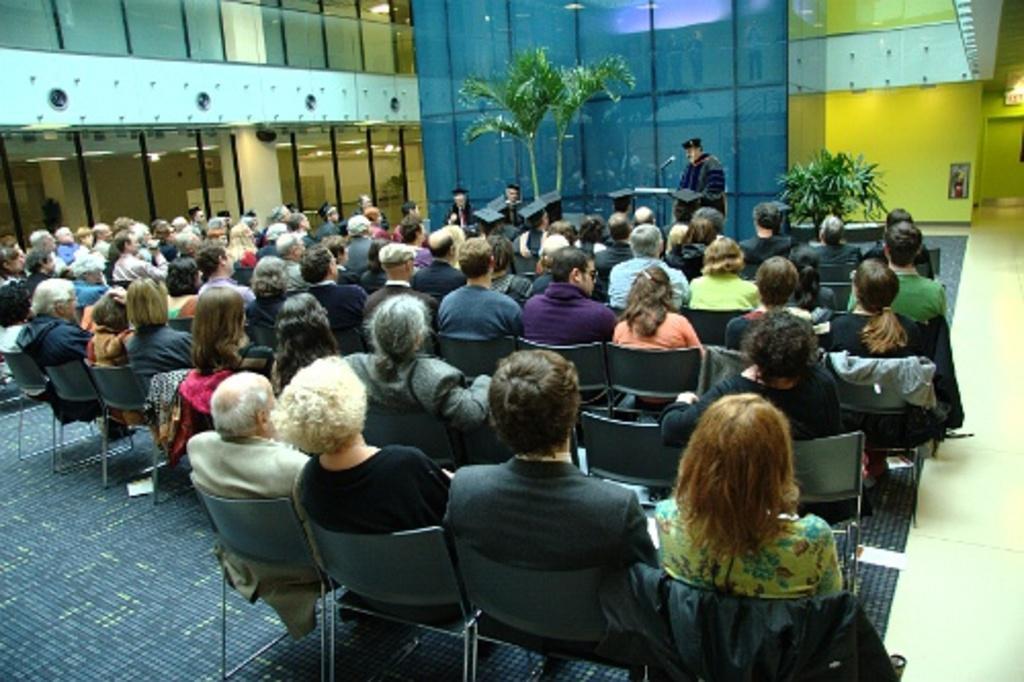Please provide a concise description of this image. There is a group of people. They are sitting on a chairs. We can see in background walls,photo frame,trees and plants. 